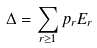Convert formula to latex. <formula><loc_0><loc_0><loc_500><loc_500>\Delta = \sum _ { r \geq 1 } p _ { r } E _ { r }</formula> 